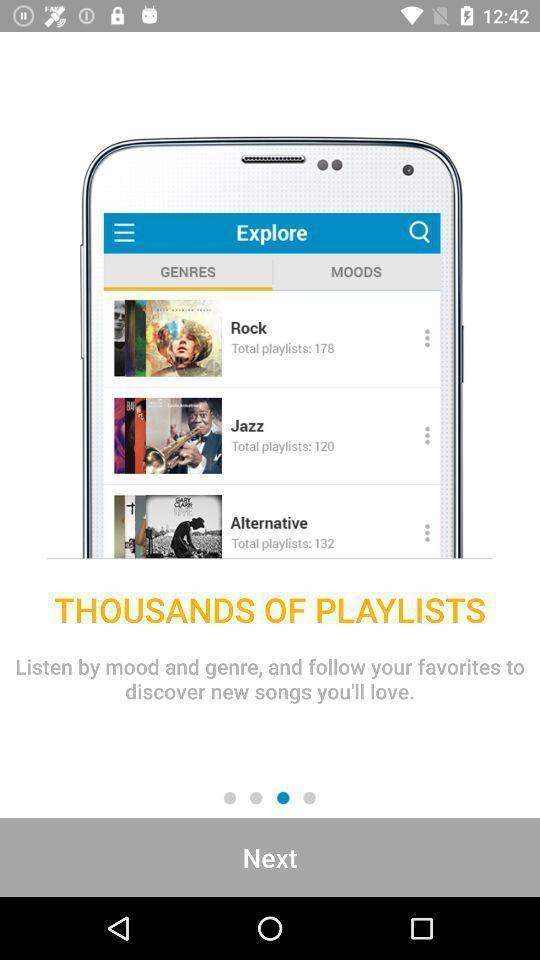Describe this image in words. Welcome page for a music player app. 